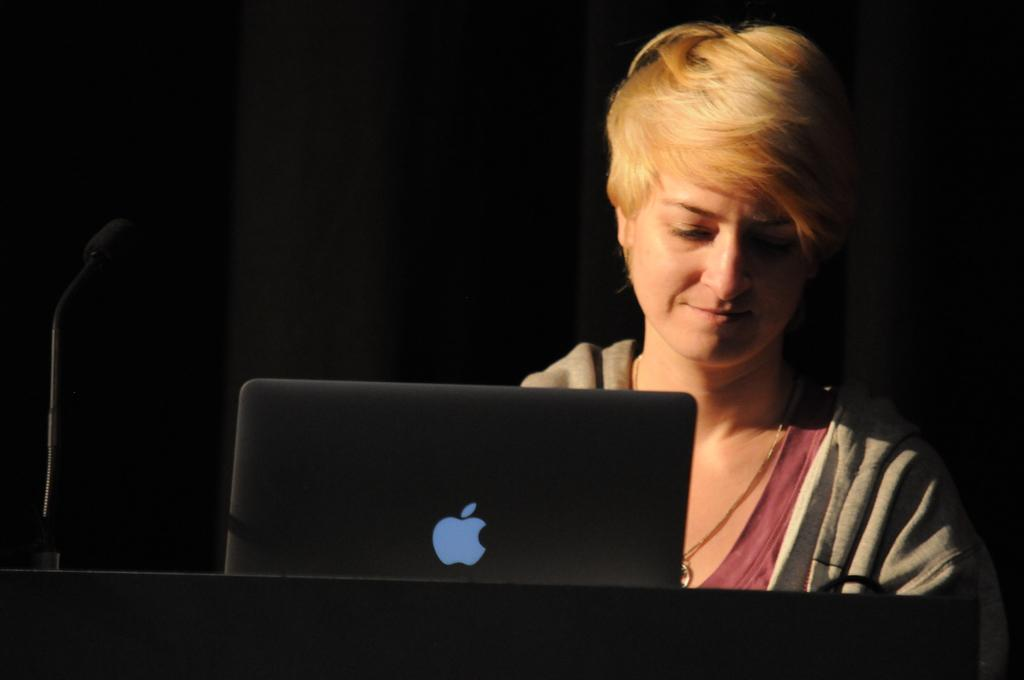Who or what is present in the image? There is a person in the image. What is the person interacting with in the image? The person is interacting with a laptop and a microphone in the image. What type of observation can be made about the zebra in the image? There is no zebra present in the image, so no observation can be made about it. 